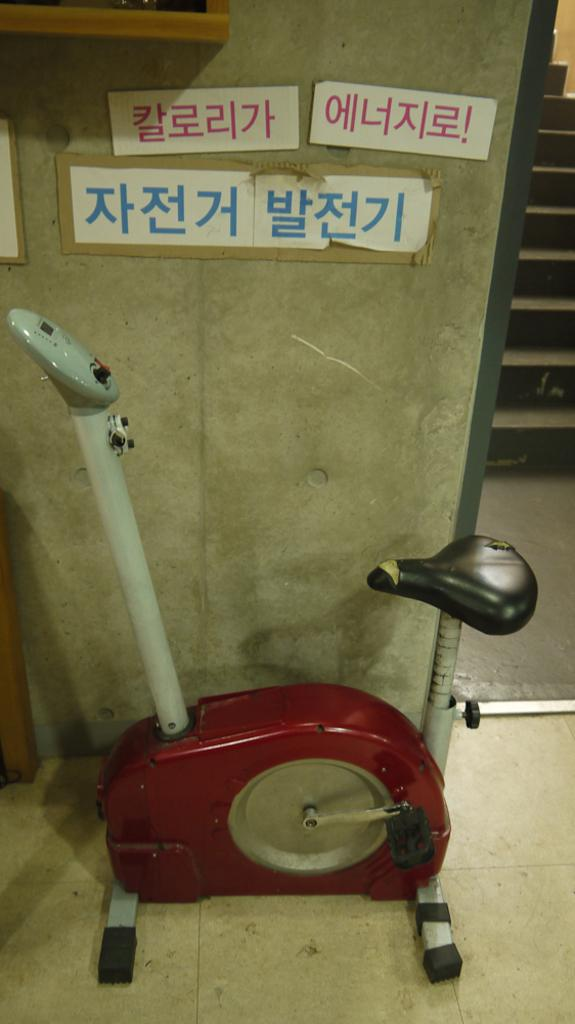Provide a one-sentence caption for the provided image. some Japanese writing that is on a wall. 